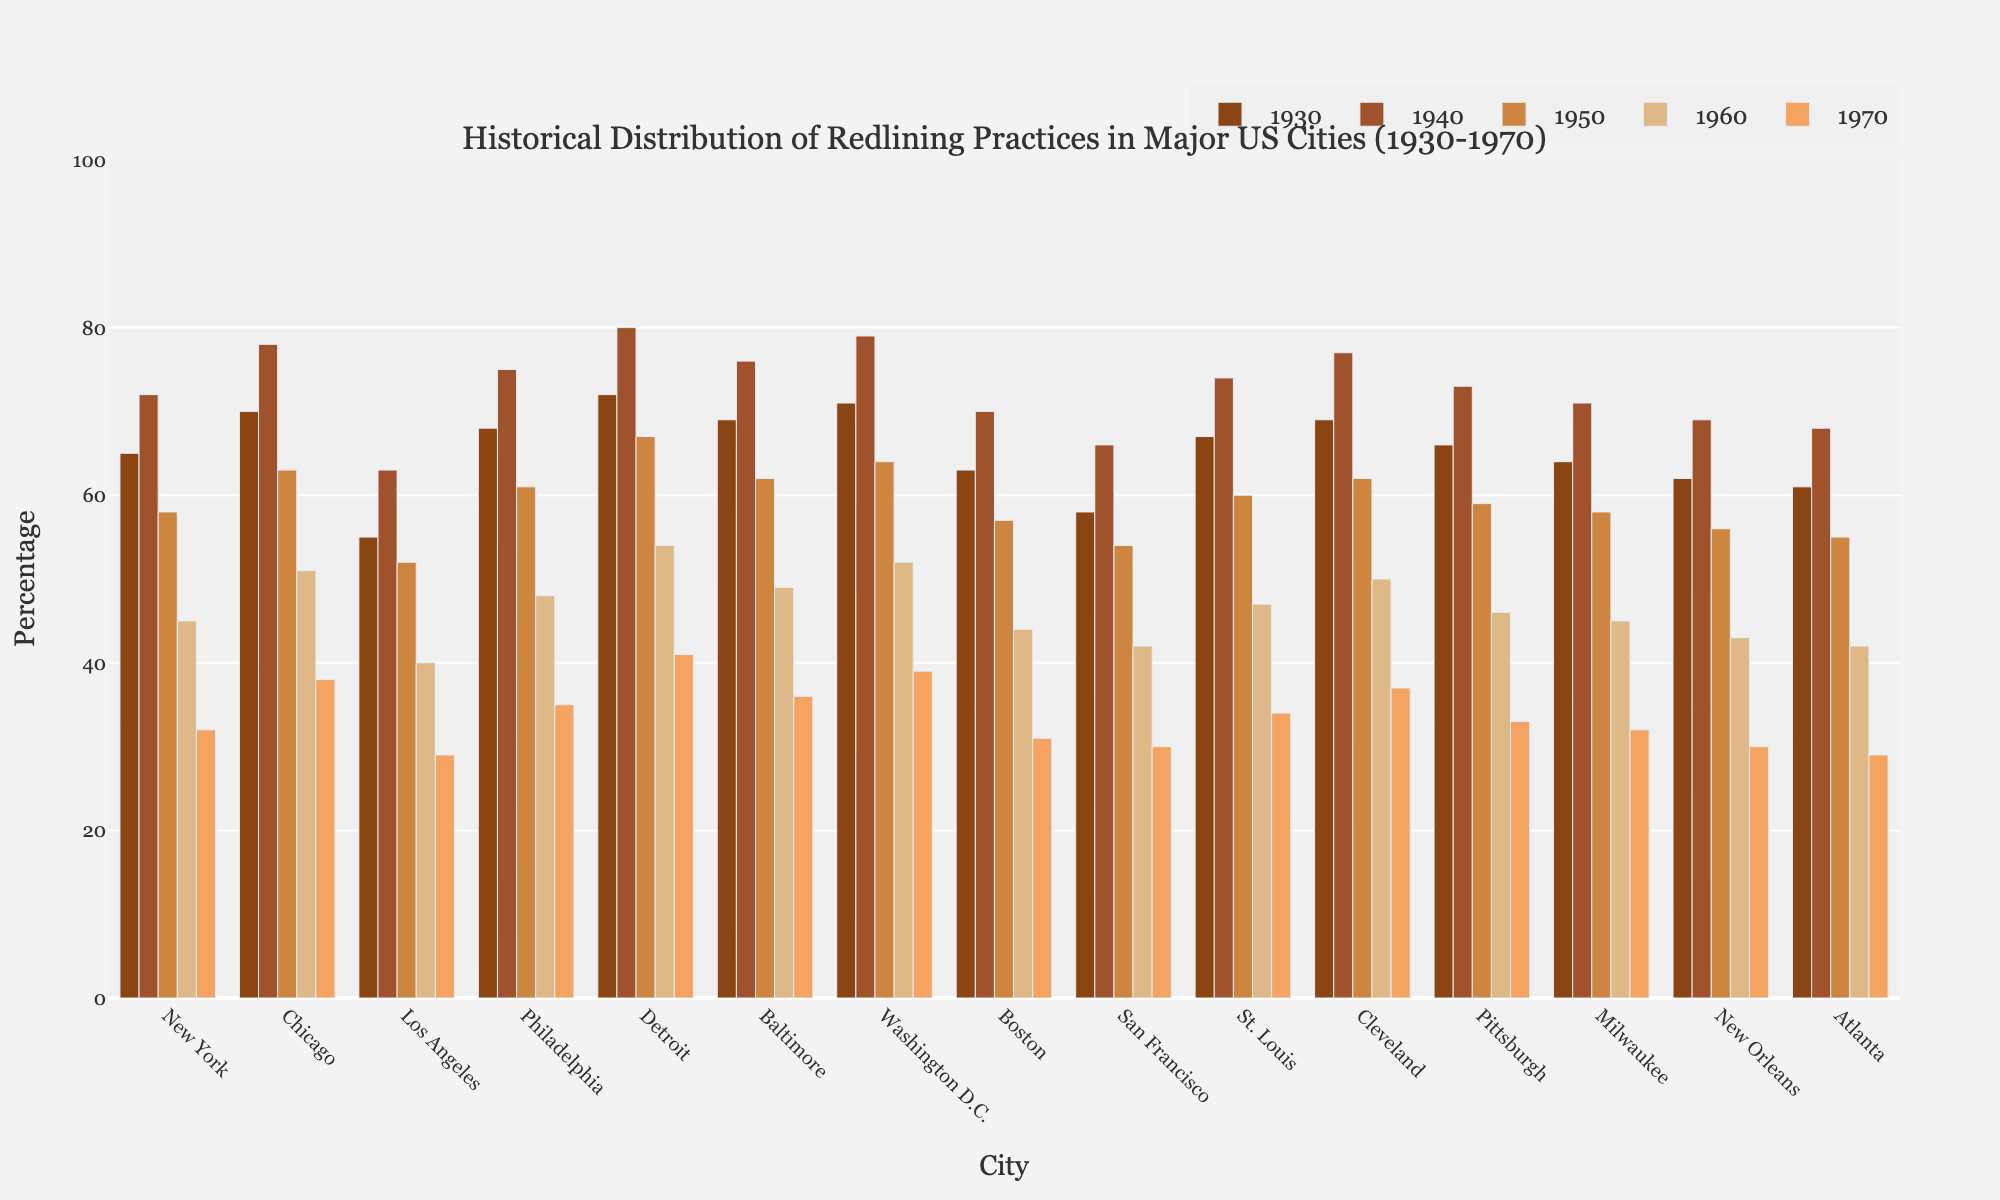What's the overall trend of redlining practices over the decades in major US cities? To determine the overall trend, examine the bars for each city across the decades from 1930 to 1970. All the bars show a decreasing pattern, indicating that redlining practices decreased over time.
Answer: Decreasing Which city had the highest percentage of redlining practices in the 1930s? Look at the bars corresponding to the 1930s for all the cities. Detroit's bar is the tallest, indicating the highest percentage of redlining practices.
Answer: Detroit In which decade did New York see the largest drop in redlining practices? Compare the differences between the heights of the bars for New York across consecutive decades. The largest drop is from 1940 to 1950, when it decreased from 72% to 58%.
Answer: 1940 to 1950 How does the percentage of redlining practices in Los Angeles in 1950 compare to that in 1970? Compare the height of the bars for Los Angeles in 1950 (52%) and 1970 (29%). The bar for 1950 is taller.
Answer: Higher in 1950 What is the average percentage of redlining practices in Boston across all decades? Sum the percentages for Boston (1930: 63, 1940: 70, 1950: 57, 1960: 44, 1970: 31) and divide by the number of decades (5). (63+70+57+44+31) / 5 = 53
Answer: 53 Which city showed the smallest decline in redlining practices from 1930 to 1970? Calculate the difference between the 1930 and 1970 bars for each city. New York shows the smallest decline (65% to 32%), which is a 33% decline.
Answer: New York Which decade had the steepest overall decline in redlining practices among all cities? Examine the bars for all cities across each decade and determine where the steepest declines occur. The steepest decline generally occurs from 1950 to 1960.
Answer: 1950 to 1960 What was the percentage of redlining in both Washington D.C. and Boston in 1940, and how do they compare? Look at the bars for Washington D.C. and Boston in 1940. Washington D.C. is at 79%, and Boston is at 70%. Washington D.C. has a higher percentage.
Answer: Higher in Washington D.C 